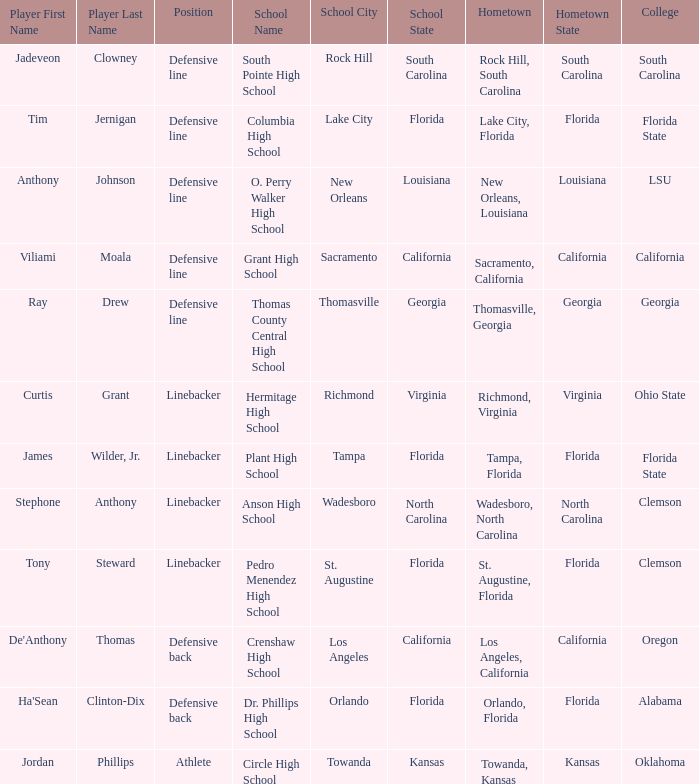Which player is from Tampa, Florida? James Wilder, Jr. 